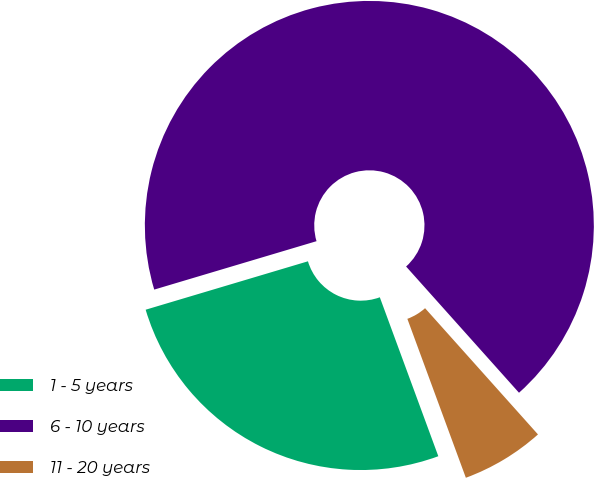Convert chart to OTSL. <chart><loc_0><loc_0><loc_500><loc_500><pie_chart><fcel>1 - 5 years<fcel>6 - 10 years<fcel>11 - 20 years<nl><fcel>26.0%<fcel>68.0%<fcel>6.0%<nl></chart> 